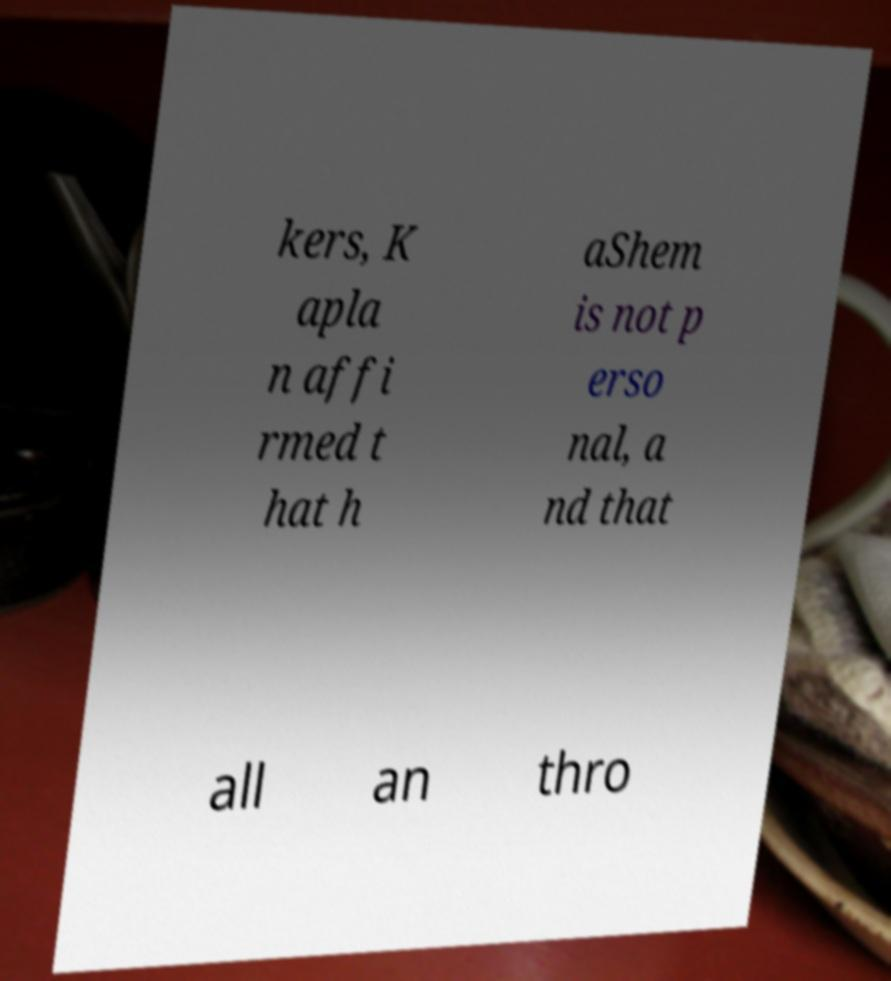For documentation purposes, I need the text within this image transcribed. Could you provide that? kers, K apla n affi rmed t hat h aShem is not p erso nal, a nd that all an thro 